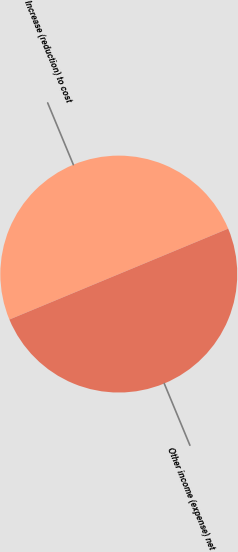Convert chart to OTSL. <chart><loc_0><loc_0><loc_500><loc_500><pie_chart><fcel>Increase (reduction) to cost<fcel>Other income (expense) net<nl><fcel>50.0%<fcel>50.0%<nl></chart> 